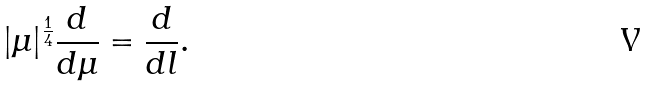Convert formula to latex. <formula><loc_0><loc_0><loc_500><loc_500>| \mu | ^ { \frac { 1 } { 4 } } \frac { d } { d \mu } = \frac { d } { d l } .</formula> 